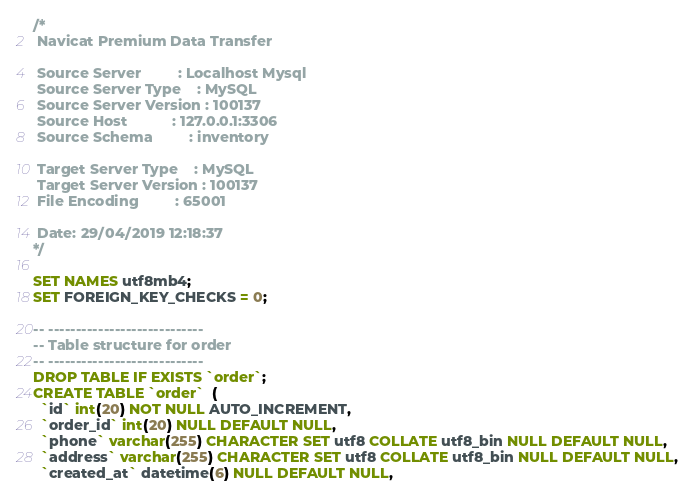Convert code to text. <code><loc_0><loc_0><loc_500><loc_500><_SQL_>/*
 Navicat Premium Data Transfer

 Source Server         : Localhost Mysql
 Source Server Type    : MySQL
 Source Server Version : 100137
 Source Host           : 127.0.0.1:3306
 Source Schema         : inventory

 Target Server Type    : MySQL
 Target Server Version : 100137
 File Encoding         : 65001

 Date: 29/04/2019 12:18:37
*/

SET NAMES utf8mb4;
SET FOREIGN_KEY_CHECKS = 0;

-- ----------------------------
-- Table structure for order
-- ----------------------------
DROP TABLE IF EXISTS `order`;
CREATE TABLE `order`  (
  `id` int(20) NOT NULL AUTO_INCREMENT,
  `order_id` int(20) NULL DEFAULT NULL,
  `phone` varchar(255) CHARACTER SET utf8 COLLATE utf8_bin NULL DEFAULT NULL,
  `address` varchar(255) CHARACTER SET utf8 COLLATE utf8_bin NULL DEFAULT NULL,
  `created_at` datetime(6) NULL DEFAULT NULL,</code> 